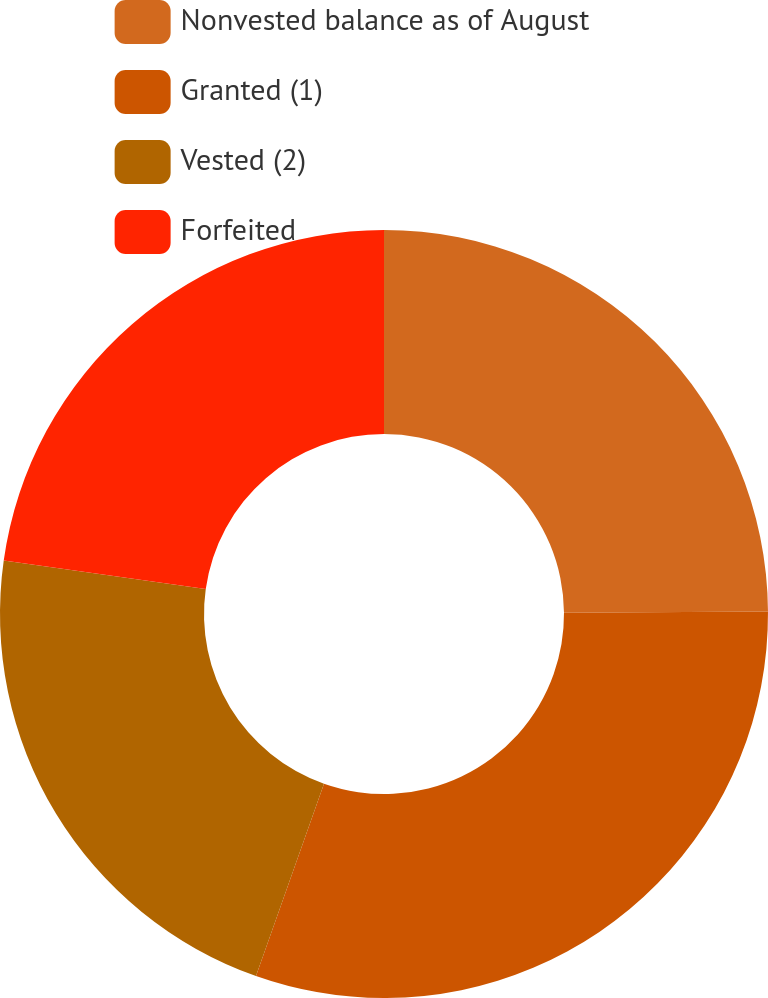Convert chart to OTSL. <chart><loc_0><loc_0><loc_500><loc_500><pie_chart><fcel>Nonvested balance as of August<fcel>Granted (1)<fcel>Vested (2)<fcel>Forfeited<nl><fcel>24.9%<fcel>30.51%<fcel>21.81%<fcel>22.78%<nl></chart> 